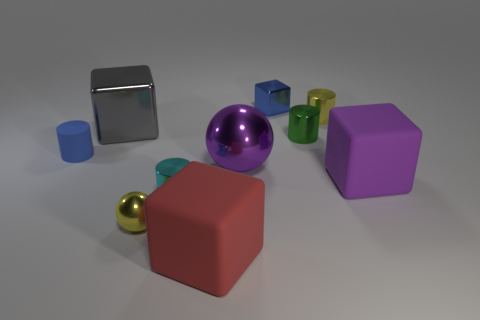Subtract 1 cubes. How many cubes are left? 3 Subtract all cubes. How many objects are left? 6 Subtract 1 green cylinders. How many objects are left? 9 Subtract all yellow metallic cylinders. Subtract all metallic blocks. How many objects are left? 7 Add 9 big red blocks. How many big red blocks are left? 10 Add 4 yellow rubber things. How many yellow rubber things exist? 4 